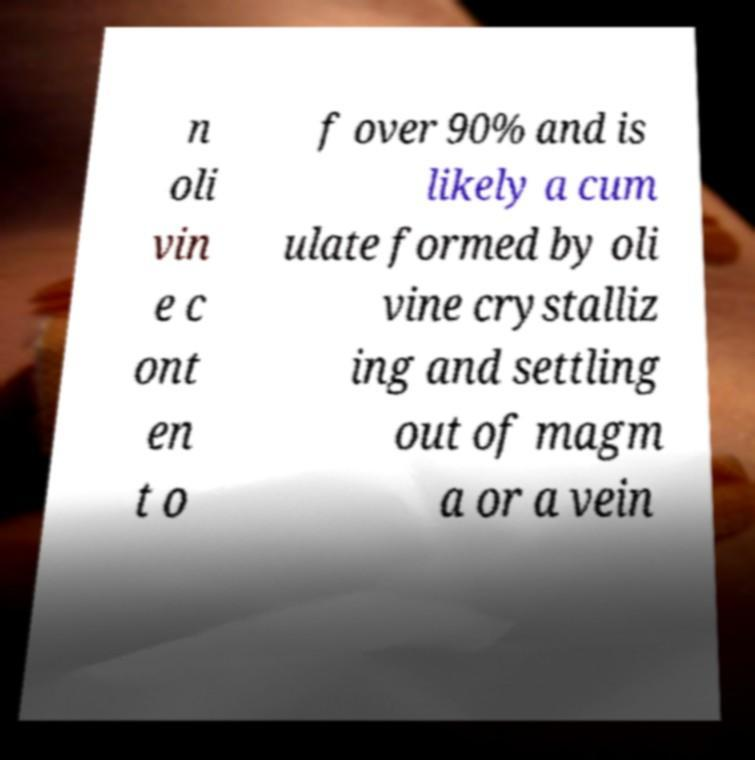Please read and relay the text visible in this image. What does it say? n oli vin e c ont en t o f over 90% and is likely a cum ulate formed by oli vine crystalliz ing and settling out of magm a or a vein 